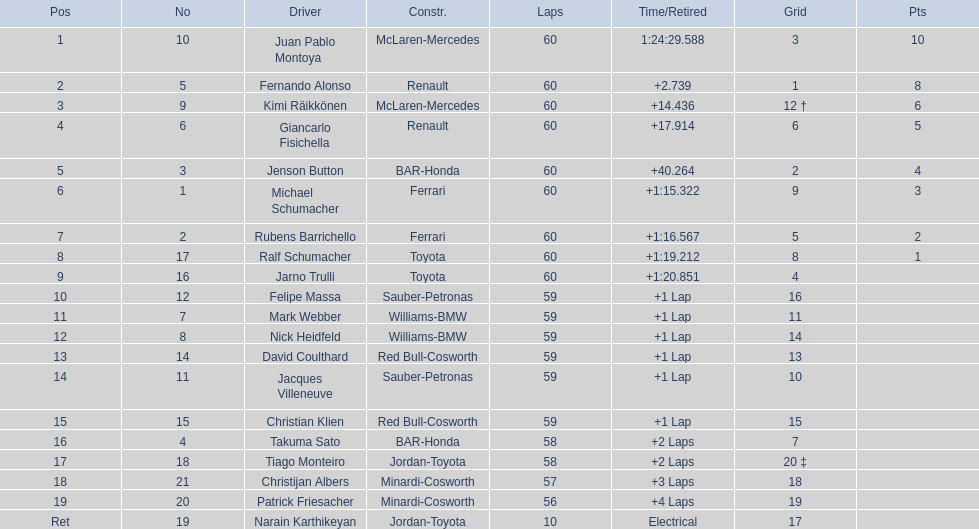Is there a points difference between the 9th position and 19th position on the list? No. 